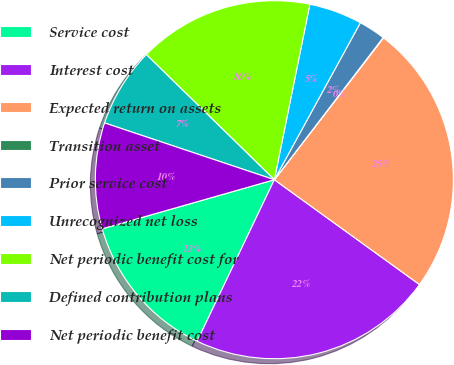Convert chart. <chart><loc_0><loc_0><loc_500><loc_500><pie_chart><fcel>Service cost<fcel>Interest cost<fcel>Expected return on assets<fcel>Transition asset<fcel>Prior service cost<fcel>Unrecognized net loss<fcel>Net periodic benefit cost for<fcel>Defined contribution plans<fcel>Net periodic benefit cost<nl><fcel>13.48%<fcel>22.14%<fcel>24.52%<fcel>0.04%<fcel>2.42%<fcel>4.8%<fcel>15.86%<fcel>7.18%<fcel>9.56%<nl></chart> 